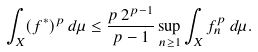<formula> <loc_0><loc_0><loc_500><loc_500>\int _ { X } ( f ^ { * } ) ^ { p } \, d \mu \leq \frac { p \, 2 ^ { p - 1 } } { p - 1 } \sup _ { n \geq 1 } \int _ { X } f _ { n } ^ { p } \, d \mu .</formula> 